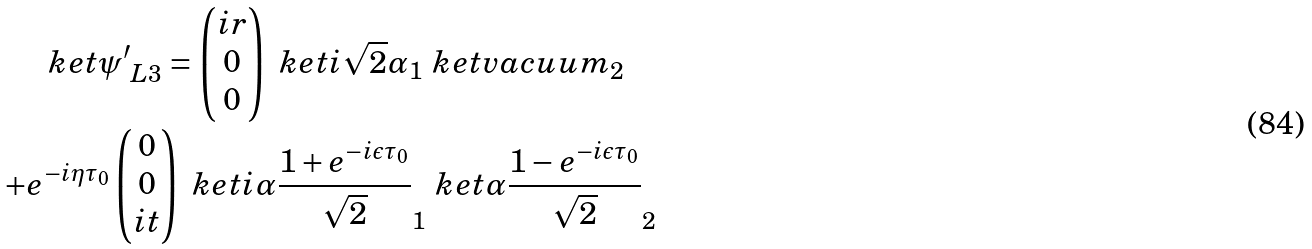<formula> <loc_0><loc_0><loc_500><loc_500>\ k e t { { \psi ^ { \prime } } _ { L 3 } } = \begin{pmatrix} i r \\ 0 \\ 0 \end{pmatrix} \ k e t { i \sqrt { 2 } \alpha } _ { 1 } \ k e t { v a c u u m } _ { 2 } \quad \\ + e ^ { - i \eta \tau _ { 0 } } \begin{pmatrix} 0 \\ 0 \\ i t \end{pmatrix} \ k e t { i \alpha \frac { 1 + e ^ { - i \epsilon \tau _ { 0 } } } { \sqrt { 2 } } } _ { 1 } \ k e t { \alpha \frac { 1 - e ^ { - i \epsilon \tau _ { 0 } } } { \sqrt { 2 } } } _ { 2 }</formula> 